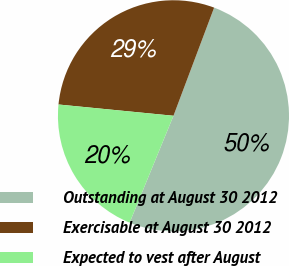Convert chart. <chart><loc_0><loc_0><loc_500><loc_500><pie_chart><fcel>Outstanding at August 30 2012<fcel>Exercisable at August 30 2012<fcel>Expected to vest after August<nl><fcel>50.47%<fcel>29.17%<fcel>20.36%<nl></chart> 